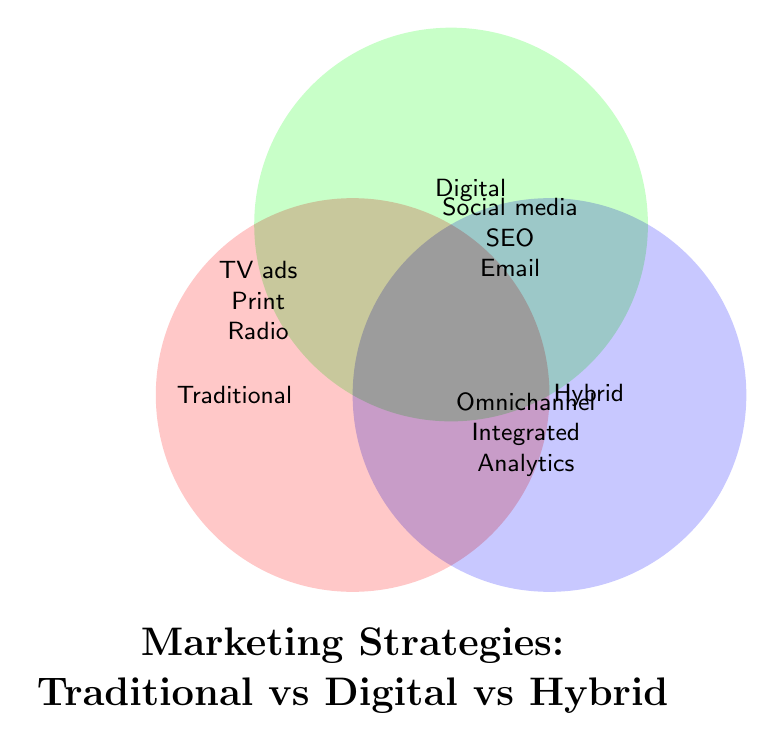What are the main marketing strategies in the Traditional section? The Traditional section includes TV commercials, Print ads, Radio spots, Billboard advertising, Trade shows, and Direct mail. These are common and widely recognized traditional forms of marketing.
Answer: TV commercials, Print ads, Radio spots, Billboard advertising, Trade shows, Direct mail Which marketing strategies appear only in the Digital section? The Digital section includes Social media ads, SEO optimization, Email marketing, Content marketing, Influencer partnerships, Pay-per-click advertising, Mobile apps, and Viral marketing. These are exclusive to digital marketing strategies.
Answer: Social media ads, SEO optimization, Email marketing, Content marketing, Influencer partnerships, Pay-per-click advertising, Mobile apps, Viral marketing What are the identified hybrid marketing strategies? Hybrid marketing strategies involve combining aspects of both traditional and digital marketing. These include Omnichannel campaigns, Integrated marketing, Cross-platform analytics, Unified brand messaging, Customer journey mapping, Personalized retargeting, Blended media buying, and Online-to-offline strategies.
Answer: Omnichannel campaigns, Integrated marketing, Cross-platform analytics, Unified brand messaging, Customer journey mapping, Personalized retargeting, Blended media buying, Online-to-offline strategies Which type of marketing exclusively uses Print ads? Print ads fall exclusively under Traditional marketing strategies. They are a type of advertising that involves physical printed media.
Answer: Traditional How many marketing strategies are listed in the Hybrid category? By counting the listed strategies in the Hybrid section, we find that there are eight in total: Omnichannel campaigns, Integrated marketing, Cross-platform analytics, Unified brand messaging, Customer journey mapping, Personalized retargeting, Blended media buying, and Online-to-offline strategies.
Answer: Eight Are there more traditional or digital marketing strategies listed? Traditional marketing has six strategies listed, while Digital marketing has eight strategies listed. By comparison, Digital marketing has more strategies than Traditional marketing.
Answer: Digital Which category includes Mobile apps as a marketing strategy? Mobile apps are listed as a marketing strategy in the Digital category. They are exclusive to digital marketing.
Answer: Digital What is the shared theme among hybrid marketing strategies? Hybrid marketing strategies focus on integrating both traditional and digital marketing approaches. They aim to create a seamless and unified experience by combining diverse channels and technologies.
Answer: Integration of traditional and digital marketing Can you name three strategies found in both Traditional and Digital categories? The figure does not display any specific strategies that are present in both Traditional and Digital categories without being included in the Hybrid section. Thus, no strategies are shared exclusively between Traditional and Digital without falling under Hybrid.
Answer: None 